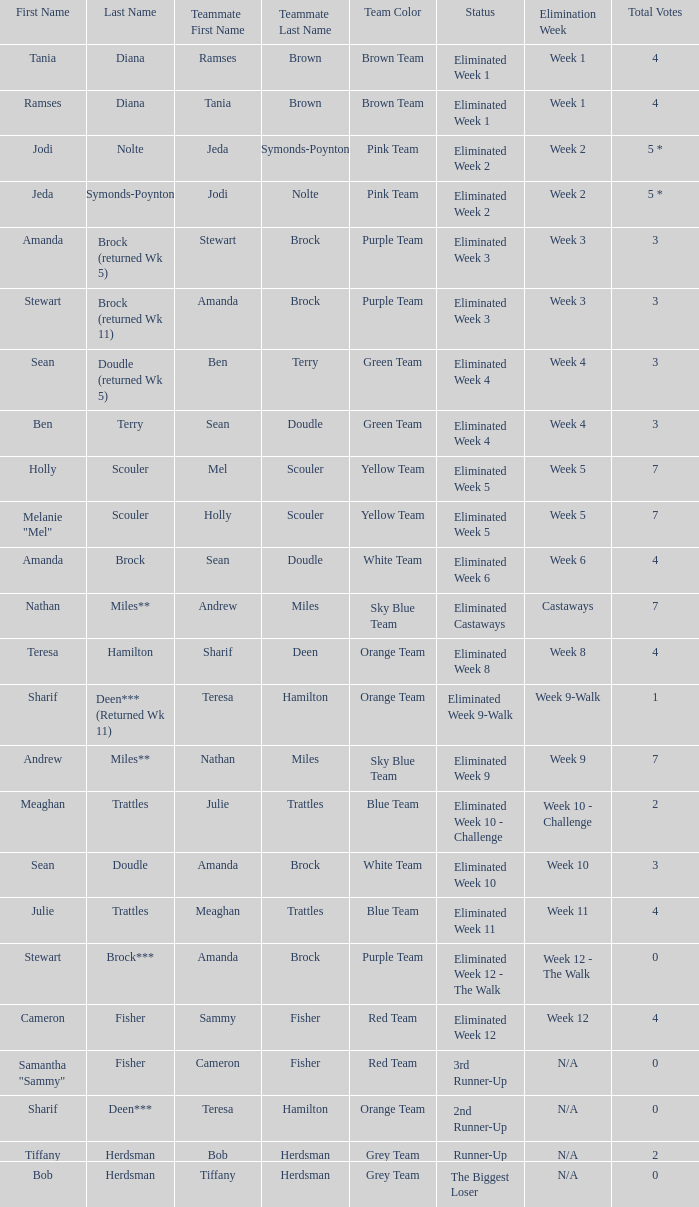Who had 0 total votes in the purple team? Eliminated Week 12 - The Walk. 